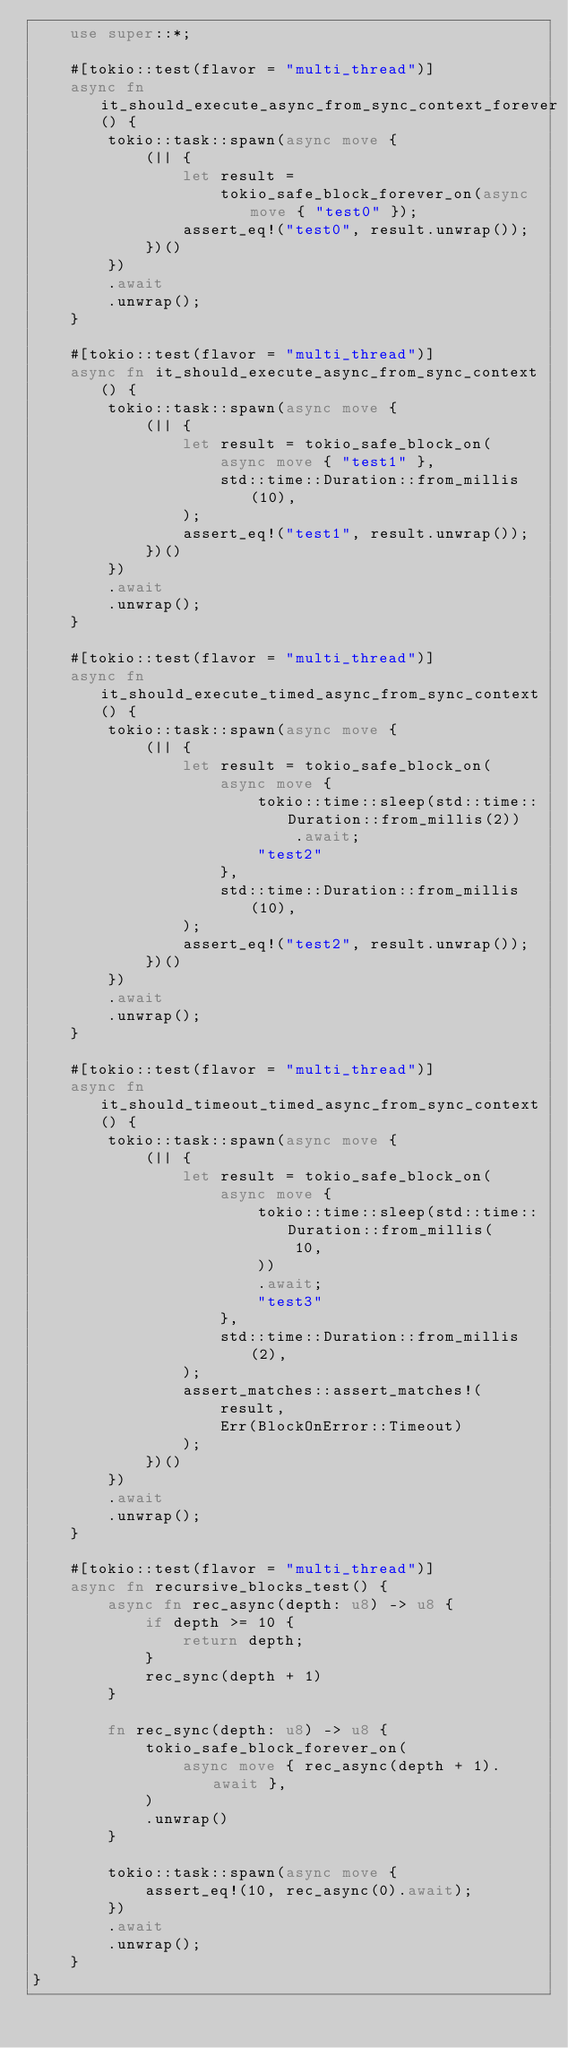<code> <loc_0><loc_0><loc_500><loc_500><_Rust_>    use super::*;

    #[tokio::test(flavor = "multi_thread")]
    async fn it_should_execute_async_from_sync_context_forever() {
        tokio::task::spawn(async move {
            (|| {
                let result =
                    tokio_safe_block_forever_on(async move { "test0" });
                assert_eq!("test0", result.unwrap());
            })()
        })
        .await
        .unwrap();
    }

    #[tokio::test(flavor = "multi_thread")]
    async fn it_should_execute_async_from_sync_context() {
        tokio::task::spawn(async move {
            (|| {
                let result = tokio_safe_block_on(
                    async move { "test1" },
                    std::time::Duration::from_millis(10),
                );
                assert_eq!("test1", result.unwrap());
            })()
        })
        .await
        .unwrap();
    }

    #[tokio::test(flavor = "multi_thread")]
    async fn it_should_execute_timed_async_from_sync_context() {
        tokio::task::spawn(async move {
            (|| {
                let result = tokio_safe_block_on(
                    async move {
                        tokio::time::sleep(std::time::Duration::from_millis(2))
                            .await;
                        "test2"
                    },
                    std::time::Duration::from_millis(10),
                );
                assert_eq!("test2", result.unwrap());
            })()
        })
        .await
        .unwrap();
    }

    #[tokio::test(flavor = "multi_thread")]
    async fn it_should_timeout_timed_async_from_sync_context() {
        tokio::task::spawn(async move {
            (|| {
                let result = tokio_safe_block_on(
                    async move {
                        tokio::time::sleep(std::time::Duration::from_millis(
                            10,
                        ))
                        .await;
                        "test3"
                    },
                    std::time::Duration::from_millis(2),
                );
                assert_matches::assert_matches!(
                    result,
                    Err(BlockOnError::Timeout)
                );
            })()
        })
        .await
        .unwrap();
    }

    #[tokio::test(flavor = "multi_thread")]
    async fn recursive_blocks_test() {
        async fn rec_async(depth: u8) -> u8 {
            if depth >= 10 {
                return depth;
            }
            rec_sync(depth + 1)
        }

        fn rec_sync(depth: u8) -> u8 {
            tokio_safe_block_forever_on(
                async move { rec_async(depth + 1).await },
            )
            .unwrap()
        }

        tokio::task::spawn(async move {
            assert_eq!(10, rec_async(0).await);
        })
        .await
        .unwrap();
    }
}
</code> 